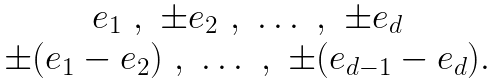<formula> <loc_0><loc_0><loc_500><loc_500>\begin{array} { c } e _ { 1 } \ , \ \pm e _ { 2 } \ , \ \dots \ , \ \pm e _ { d } \\ \pm ( e _ { 1 } - e _ { 2 } ) \ , \ \dots \ , \ \pm ( e _ { d - 1 } - e _ { d } ) . \end{array}</formula> 